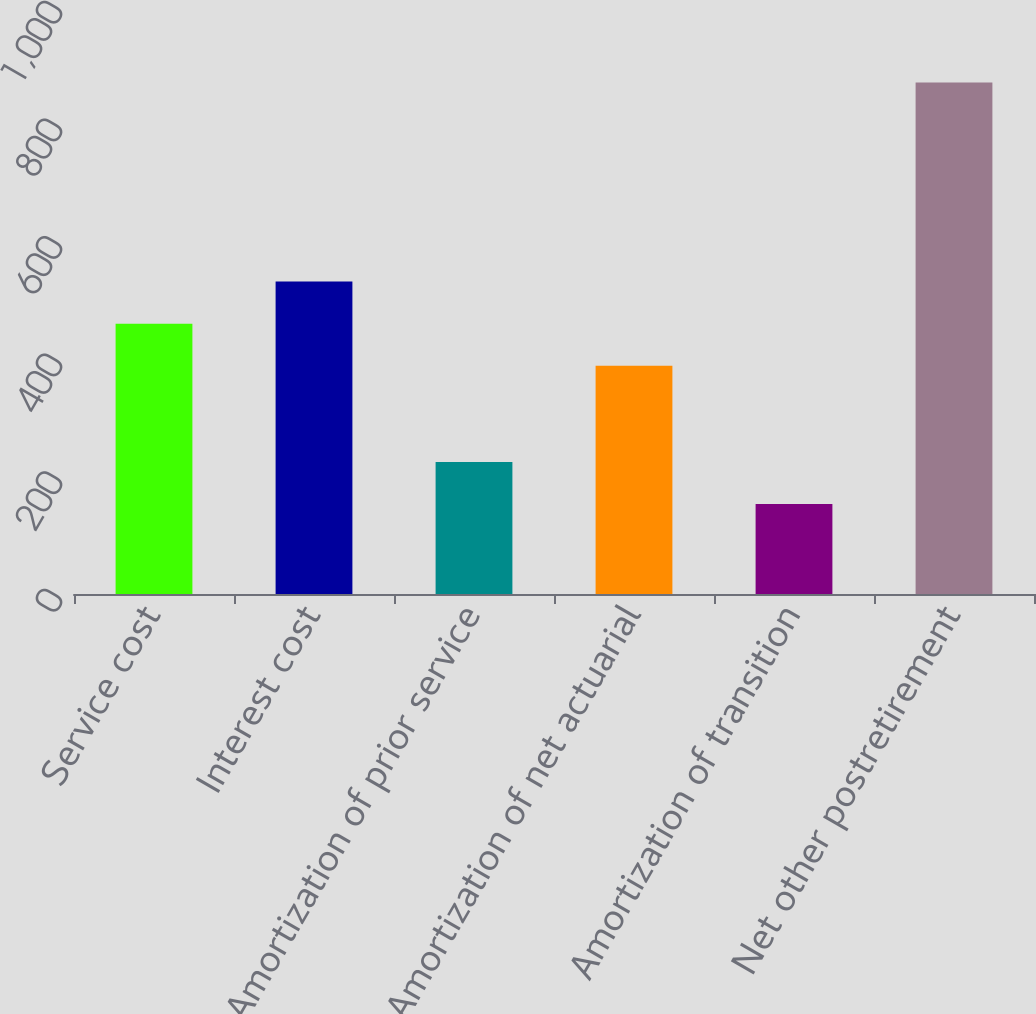Convert chart to OTSL. <chart><loc_0><loc_0><loc_500><loc_500><bar_chart><fcel>Service cost<fcel>Interest cost<fcel>Amortization of prior service<fcel>Amortization of net actuarial<fcel>Amortization of transition<fcel>Net other postretirement<nl><fcel>459.7<fcel>531.4<fcel>224.7<fcel>388<fcel>153<fcel>870<nl></chart> 